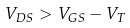<formula> <loc_0><loc_0><loc_500><loc_500>V _ { D S } > V _ { G S } - V _ { T }</formula> 